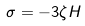<formula> <loc_0><loc_0><loc_500><loc_500>\sigma = - 3 \zeta H</formula> 